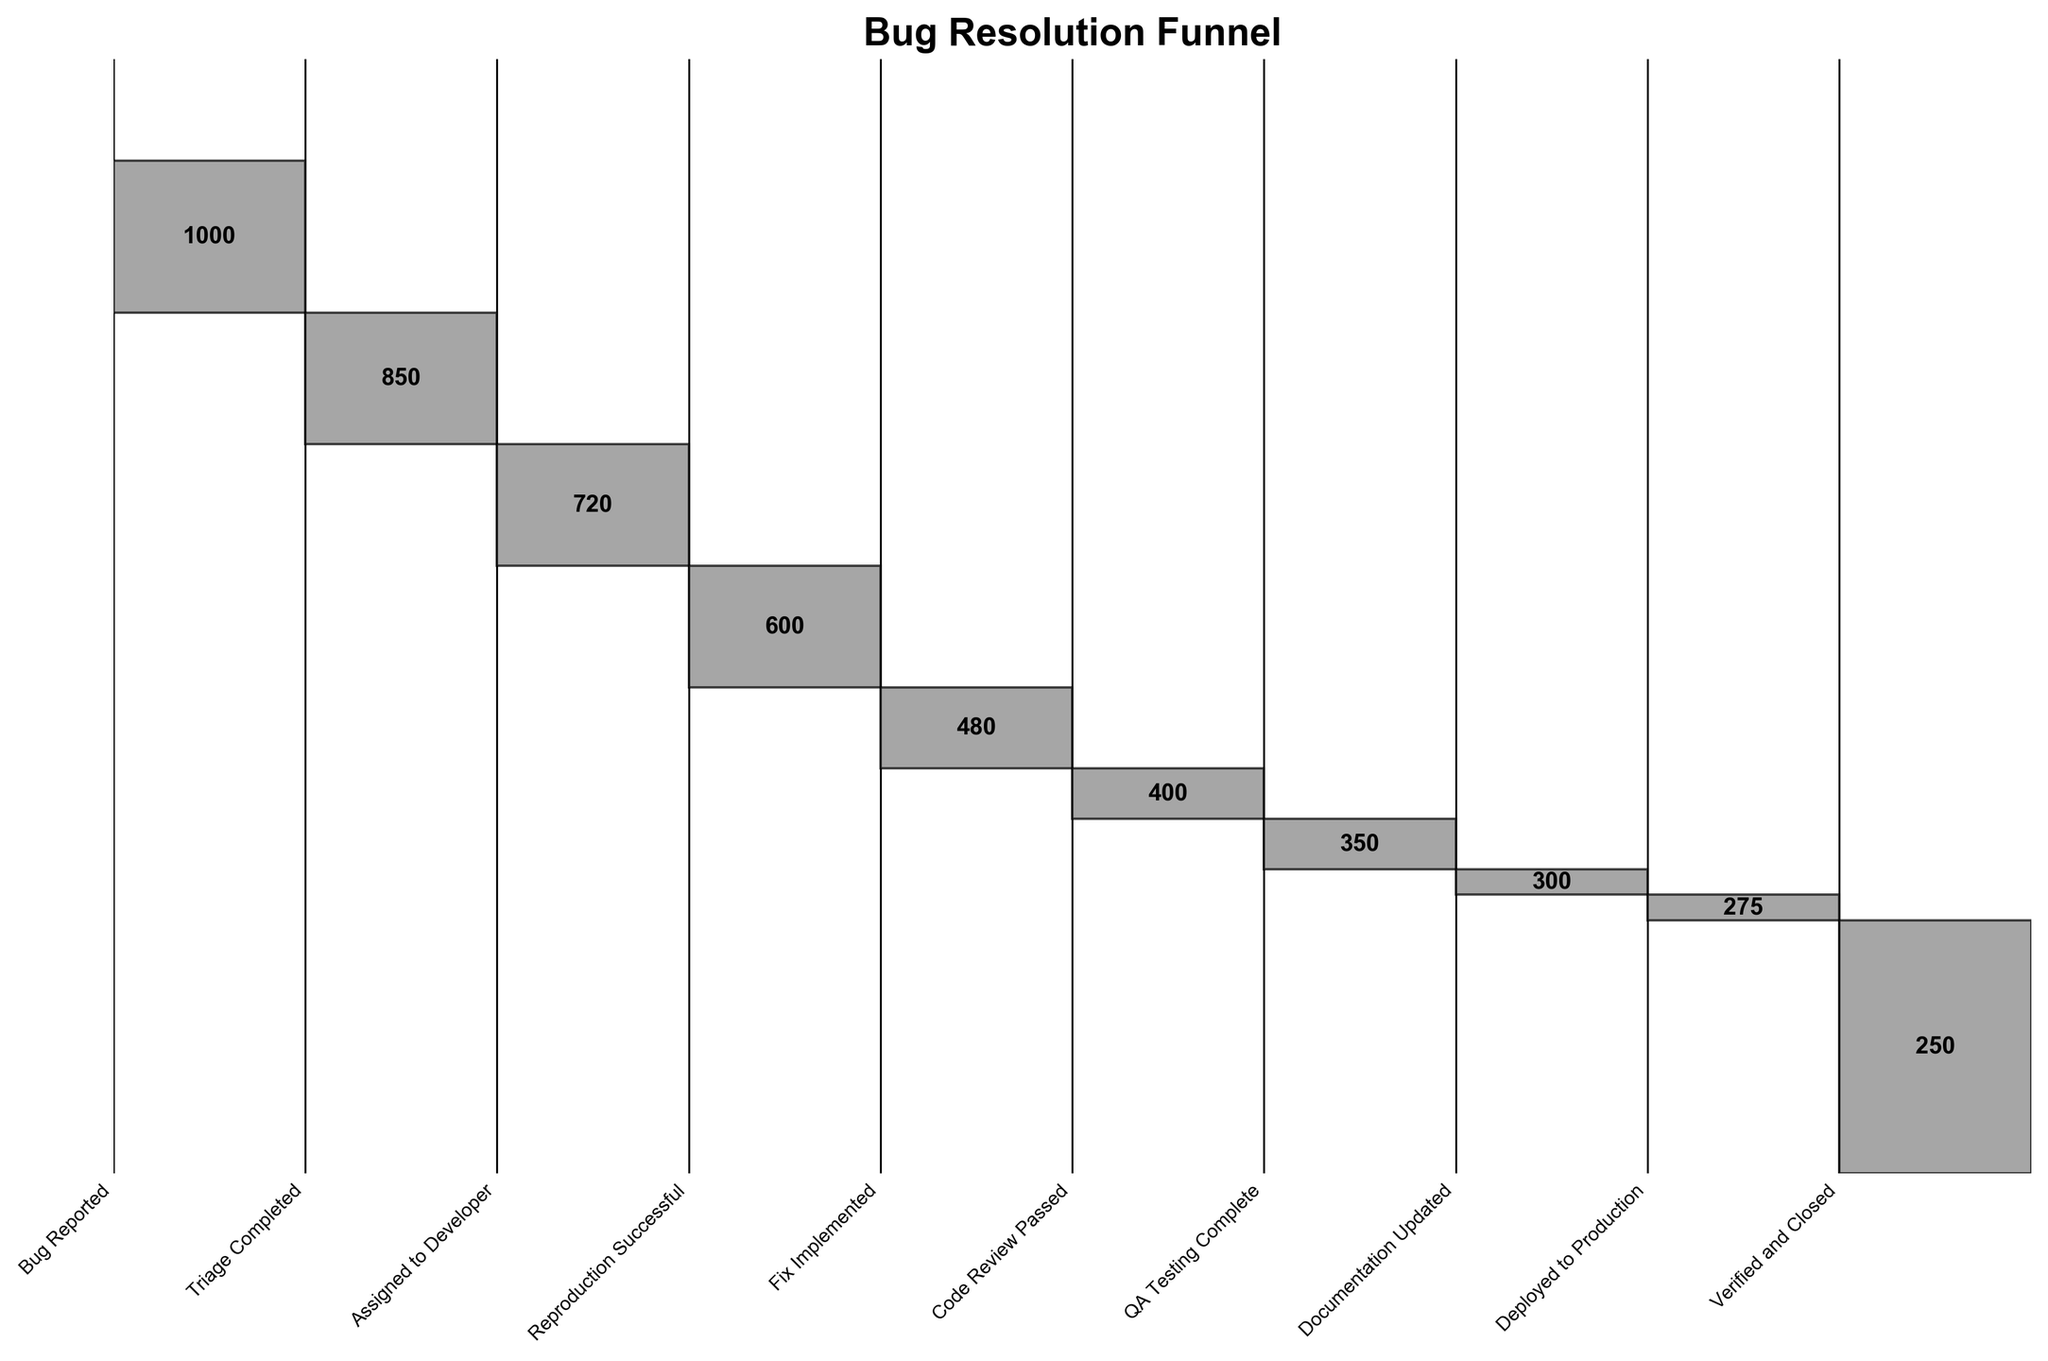what is the title of the figure? The title of the figure is displayed prominently at the top in a bold and larger font size. It provides a concise description of the chart.
Answer: Bug Resolution Funnel how many stages are there in the bug resolution process? Count the number of distinct stages listed on the x-axis of the figure. Each stage is a label beneath a bar.
Answer: 10 how many bugs were successfully deployed to production? Locate the bar labeled 'Deployed to Production' on the x-axis and read the corresponding value indicated in the middle of the bar.
Answer: 275 how many more bugs were passed in code review compared to QA testing complete? Find the values for 'Code Review Passed' and 'QA Testing Complete', then compute the difference between these values: 400 (code review) - 350 (QA testing).
Answer: 50 what percentage of bugs were resolved out of the total reported bugs? Divide the number of bugs 'Verified and Closed' by the number of 'Bug Reported' and multiply by 100 to get the percentage: (250/1000) * 100.
Answer: 25% which stage saw the most significant drop in the number of bugs? Observe the differences between the counts of consecutive stages and identify the pair with the largest difference. The biggest drop is from 'Reproduction Successful' (600) to 'Fix Implemented' (480).
Answer: Reproduction Successful to Fix Implemented is the number of bugs assigned to a developer larger than the number of bugs in triage completed? Compare the values: 'Assigned to Developer' is 720, 'Triage Completed' is 850. Since 720 < 850, the number assigned to a developer is not larger.
Answer: No what is the sum of bugs that passed code review and those that were confirmed successful in QA testing? Add the two values together: 400 (code review) + 350 (QA testing).
Answer: 750 what is the average number of bugs across all stages in the process? Sum all the bug counts and divide by the number of stages: (1000 + 850 + 720 + 600 + 480 + 400 + 350 + 300 + 275 + 250) / 10.
Answer: 522.5 what stages had more than 500 bugs? Identify all bars whose counts are above 500 from the x-axis labels. The stages with more than 500 bugs are 'Bug Reported', 'Triage Completed', 'Assigned to Developer', and 'Reproduction Successful'.
Answer: Bug Reported, Triage Completed, Assigned to Developer, Reproduction Successful 